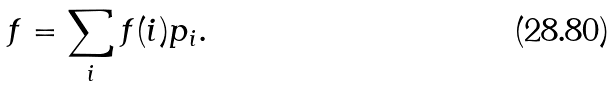Convert formula to latex. <formula><loc_0><loc_0><loc_500><loc_500>f = \sum _ { i } f ( i ) p _ { i } .</formula> 